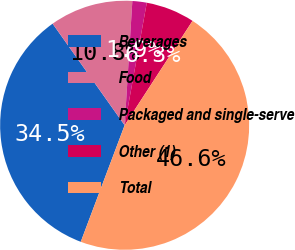Convert chart. <chart><loc_0><loc_0><loc_500><loc_500><pie_chart><fcel>Beverages<fcel>Food<fcel>Packaged and single-serve<fcel>Other (1)<fcel>Total<nl><fcel>34.45%<fcel>10.8%<fcel>1.86%<fcel>6.33%<fcel>46.55%<nl></chart> 